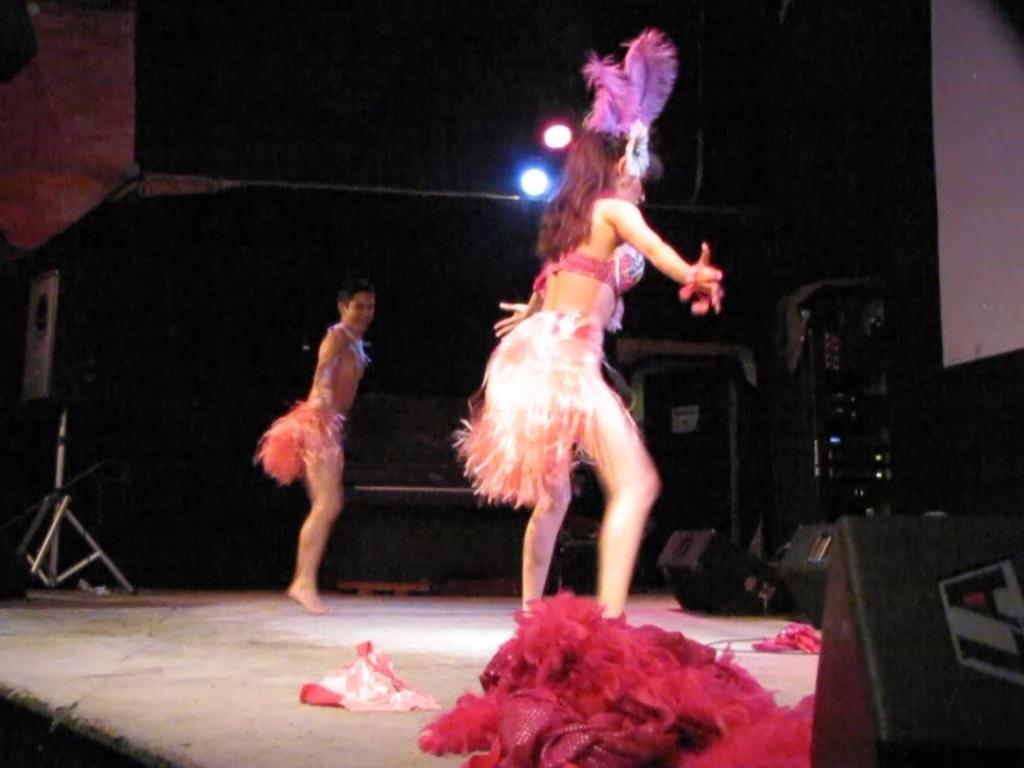How many people are in the image? There are two persons standing in the image. What are the people wearing? The persons are wearing clothes. What can be seen on the left side of the image? There is a speaker on the left side of the image. What is located on the right side of the image? There is an equipment on the right side of the image. What type of knot is being tied by the persons in the image? There is no knot being tied in the image; the persons are simply standing. How many things are present in the image? It is not necessary to count the number of things in the image, as the focus is on the two persons and the objects on each side. 